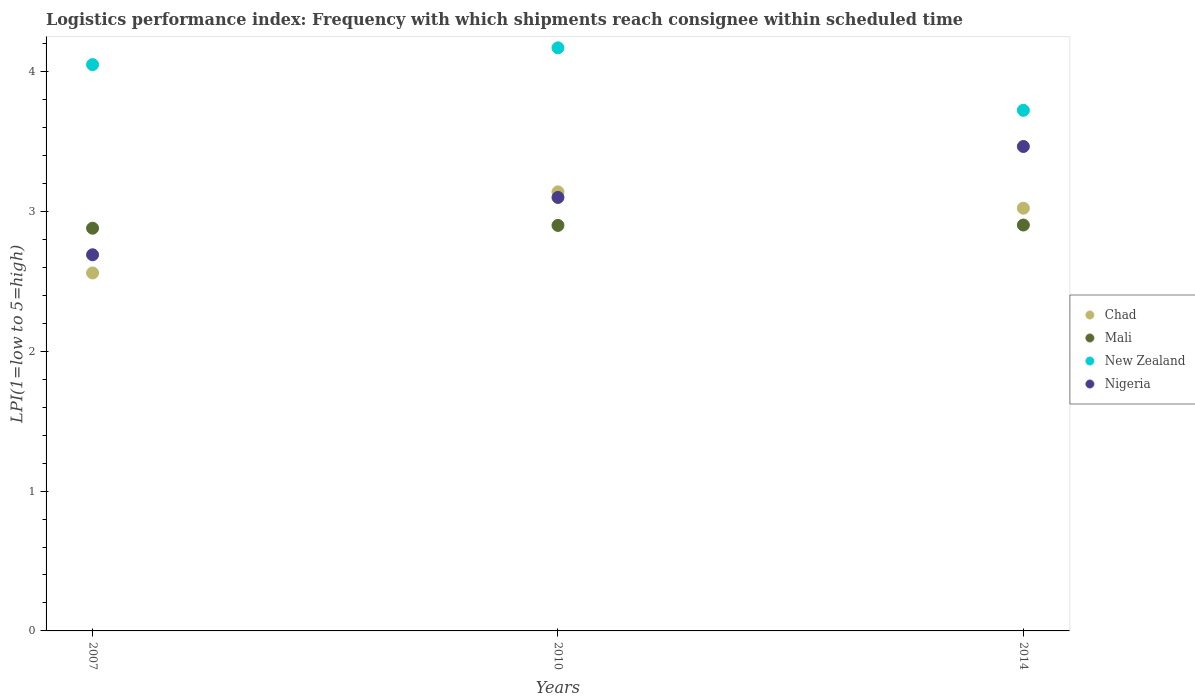What is the logistics performance index in Mali in 2014?
Your response must be concise. 2.9. Across all years, what is the maximum logistics performance index in Chad?
Offer a terse response. 3.14. Across all years, what is the minimum logistics performance index in Nigeria?
Your answer should be compact. 2.69. In which year was the logistics performance index in New Zealand minimum?
Offer a very short reply. 2014. What is the total logistics performance index in Chad in the graph?
Make the answer very short. 8.72. What is the difference between the logistics performance index in Nigeria in 2010 and that in 2014?
Offer a very short reply. -0.36. What is the difference between the logistics performance index in Chad in 2007 and the logistics performance index in Mali in 2010?
Your answer should be very brief. -0.34. What is the average logistics performance index in Mali per year?
Keep it short and to the point. 2.89. In the year 2007, what is the difference between the logistics performance index in Mali and logistics performance index in Nigeria?
Give a very brief answer. 0.19. In how many years, is the logistics performance index in Chad greater than 3.2?
Provide a succinct answer. 0. What is the ratio of the logistics performance index in New Zealand in 2007 to that in 2010?
Ensure brevity in your answer.  0.97. Is the logistics performance index in Nigeria in 2007 less than that in 2010?
Offer a terse response. Yes. What is the difference between the highest and the second highest logistics performance index in Nigeria?
Keep it short and to the point. 0.36. What is the difference between the highest and the lowest logistics performance index in Nigeria?
Provide a succinct answer. 0.77. Is the sum of the logistics performance index in Nigeria in 2007 and 2014 greater than the maximum logistics performance index in New Zealand across all years?
Provide a short and direct response. Yes. Is it the case that in every year, the sum of the logistics performance index in New Zealand and logistics performance index in Chad  is greater than the sum of logistics performance index in Mali and logistics performance index in Nigeria?
Provide a short and direct response. Yes. Is it the case that in every year, the sum of the logistics performance index in Chad and logistics performance index in Mali  is greater than the logistics performance index in Nigeria?
Make the answer very short. Yes. Does the logistics performance index in Nigeria monotonically increase over the years?
Ensure brevity in your answer.  Yes. Is the logistics performance index in Mali strictly greater than the logistics performance index in New Zealand over the years?
Ensure brevity in your answer.  No. Is the logistics performance index in Nigeria strictly less than the logistics performance index in Chad over the years?
Offer a very short reply. No. What is the difference between two consecutive major ticks on the Y-axis?
Provide a succinct answer. 1. Are the values on the major ticks of Y-axis written in scientific E-notation?
Your answer should be very brief. No. Does the graph contain any zero values?
Provide a succinct answer. No. Does the graph contain grids?
Ensure brevity in your answer.  No. Where does the legend appear in the graph?
Ensure brevity in your answer.  Center right. How many legend labels are there?
Provide a succinct answer. 4. How are the legend labels stacked?
Your answer should be very brief. Vertical. What is the title of the graph?
Offer a terse response. Logistics performance index: Frequency with which shipments reach consignee within scheduled time. Does "Yemen, Rep." appear as one of the legend labels in the graph?
Your answer should be compact. No. What is the label or title of the Y-axis?
Your response must be concise. LPI(1=low to 5=high). What is the LPI(1=low to 5=high) in Chad in 2007?
Your response must be concise. 2.56. What is the LPI(1=low to 5=high) in Mali in 2007?
Provide a succinct answer. 2.88. What is the LPI(1=low to 5=high) of New Zealand in 2007?
Ensure brevity in your answer.  4.05. What is the LPI(1=low to 5=high) in Nigeria in 2007?
Provide a short and direct response. 2.69. What is the LPI(1=low to 5=high) of Chad in 2010?
Make the answer very short. 3.14. What is the LPI(1=low to 5=high) of Mali in 2010?
Offer a terse response. 2.9. What is the LPI(1=low to 5=high) of New Zealand in 2010?
Provide a succinct answer. 4.17. What is the LPI(1=low to 5=high) in Nigeria in 2010?
Make the answer very short. 3.1. What is the LPI(1=low to 5=high) in Chad in 2014?
Provide a succinct answer. 3.02. What is the LPI(1=low to 5=high) in Mali in 2014?
Your response must be concise. 2.9. What is the LPI(1=low to 5=high) of New Zealand in 2014?
Keep it short and to the point. 3.72. What is the LPI(1=low to 5=high) of Nigeria in 2014?
Offer a very short reply. 3.46. Across all years, what is the maximum LPI(1=low to 5=high) of Chad?
Make the answer very short. 3.14. Across all years, what is the maximum LPI(1=low to 5=high) of Mali?
Your response must be concise. 2.9. Across all years, what is the maximum LPI(1=low to 5=high) of New Zealand?
Provide a succinct answer. 4.17. Across all years, what is the maximum LPI(1=low to 5=high) of Nigeria?
Ensure brevity in your answer.  3.46. Across all years, what is the minimum LPI(1=low to 5=high) in Chad?
Keep it short and to the point. 2.56. Across all years, what is the minimum LPI(1=low to 5=high) of Mali?
Provide a short and direct response. 2.88. Across all years, what is the minimum LPI(1=low to 5=high) of New Zealand?
Make the answer very short. 3.72. Across all years, what is the minimum LPI(1=low to 5=high) of Nigeria?
Your answer should be very brief. 2.69. What is the total LPI(1=low to 5=high) in Chad in the graph?
Keep it short and to the point. 8.72. What is the total LPI(1=low to 5=high) in Mali in the graph?
Offer a very short reply. 8.68. What is the total LPI(1=low to 5=high) in New Zealand in the graph?
Keep it short and to the point. 11.94. What is the total LPI(1=low to 5=high) of Nigeria in the graph?
Make the answer very short. 9.25. What is the difference between the LPI(1=low to 5=high) of Chad in 2007 and that in 2010?
Your answer should be very brief. -0.58. What is the difference between the LPI(1=low to 5=high) in Mali in 2007 and that in 2010?
Make the answer very short. -0.02. What is the difference between the LPI(1=low to 5=high) of New Zealand in 2007 and that in 2010?
Ensure brevity in your answer.  -0.12. What is the difference between the LPI(1=low to 5=high) in Nigeria in 2007 and that in 2010?
Give a very brief answer. -0.41. What is the difference between the LPI(1=low to 5=high) of Chad in 2007 and that in 2014?
Offer a very short reply. -0.46. What is the difference between the LPI(1=low to 5=high) of Mali in 2007 and that in 2014?
Offer a very short reply. -0.02. What is the difference between the LPI(1=low to 5=high) in New Zealand in 2007 and that in 2014?
Give a very brief answer. 0.33. What is the difference between the LPI(1=low to 5=high) of Nigeria in 2007 and that in 2014?
Make the answer very short. -0.77. What is the difference between the LPI(1=low to 5=high) of Chad in 2010 and that in 2014?
Your answer should be compact. 0.12. What is the difference between the LPI(1=low to 5=high) in Mali in 2010 and that in 2014?
Your response must be concise. -0. What is the difference between the LPI(1=low to 5=high) of New Zealand in 2010 and that in 2014?
Ensure brevity in your answer.  0.45. What is the difference between the LPI(1=low to 5=high) of Nigeria in 2010 and that in 2014?
Provide a short and direct response. -0.36. What is the difference between the LPI(1=low to 5=high) of Chad in 2007 and the LPI(1=low to 5=high) of Mali in 2010?
Your answer should be compact. -0.34. What is the difference between the LPI(1=low to 5=high) of Chad in 2007 and the LPI(1=low to 5=high) of New Zealand in 2010?
Your answer should be compact. -1.61. What is the difference between the LPI(1=low to 5=high) in Chad in 2007 and the LPI(1=low to 5=high) in Nigeria in 2010?
Ensure brevity in your answer.  -0.54. What is the difference between the LPI(1=low to 5=high) in Mali in 2007 and the LPI(1=low to 5=high) in New Zealand in 2010?
Provide a succinct answer. -1.29. What is the difference between the LPI(1=low to 5=high) of Mali in 2007 and the LPI(1=low to 5=high) of Nigeria in 2010?
Give a very brief answer. -0.22. What is the difference between the LPI(1=low to 5=high) in Chad in 2007 and the LPI(1=low to 5=high) in Mali in 2014?
Give a very brief answer. -0.34. What is the difference between the LPI(1=low to 5=high) in Chad in 2007 and the LPI(1=low to 5=high) in New Zealand in 2014?
Offer a very short reply. -1.16. What is the difference between the LPI(1=low to 5=high) in Chad in 2007 and the LPI(1=low to 5=high) in Nigeria in 2014?
Provide a short and direct response. -0.9. What is the difference between the LPI(1=low to 5=high) in Mali in 2007 and the LPI(1=low to 5=high) in New Zealand in 2014?
Provide a succinct answer. -0.84. What is the difference between the LPI(1=low to 5=high) of Mali in 2007 and the LPI(1=low to 5=high) of Nigeria in 2014?
Offer a very short reply. -0.58. What is the difference between the LPI(1=low to 5=high) of New Zealand in 2007 and the LPI(1=low to 5=high) of Nigeria in 2014?
Give a very brief answer. 0.59. What is the difference between the LPI(1=low to 5=high) of Chad in 2010 and the LPI(1=low to 5=high) of Mali in 2014?
Your answer should be compact. 0.24. What is the difference between the LPI(1=low to 5=high) in Chad in 2010 and the LPI(1=low to 5=high) in New Zealand in 2014?
Keep it short and to the point. -0.58. What is the difference between the LPI(1=low to 5=high) of Chad in 2010 and the LPI(1=low to 5=high) of Nigeria in 2014?
Ensure brevity in your answer.  -0.32. What is the difference between the LPI(1=low to 5=high) of Mali in 2010 and the LPI(1=low to 5=high) of New Zealand in 2014?
Your answer should be very brief. -0.82. What is the difference between the LPI(1=low to 5=high) in Mali in 2010 and the LPI(1=low to 5=high) in Nigeria in 2014?
Your answer should be very brief. -0.56. What is the difference between the LPI(1=low to 5=high) in New Zealand in 2010 and the LPI(1=low to 5=high) in Nigeria in 2014?
Ensure brevity in your answer.  0.71. What is the average LPI(1=low to 5=high) in Chad per year?
Keep it short and to the point. 2.91. What is the average LPI(1=low to 5=high) of Mali per year?
Provide a succinct answer. 2.89. What is the average LPI(1=low to 5=high) of New Zealand per year?
Keep it short and to the point. 3.98. What is the average LPI(1=low to 5=high) of Nigeria per year?
Make the answer very short. 3.08. In the year 2007, what is the difference between the LPI(1=low to 5=high) in Chad and LPI(1=low to 5=high) in Mali?
Your answer should be very brief. -0.32. In the year 2007, what is the difference between the LPI(1=low to 5=high) of Chad and LPI(1=low to 5=high) of New Zealand?
Your answer should be very brief. -1.49. In the year 2007, what is the difference between the LPI(1=low to 5=high) in Chad and LPI(1=low to 5=high) in Nigeria?
Your answer should be compact. -0.13. In the year 2007, what is the difference between the LPI(1=low to 5=high) in Mali and LPI(1=low to 5=high) in New Zealand?
Make the answer very short. -1.17. In the year 2007, what is the difference between the LPI(1=low to 5=high) in Mali and LPI(1=low to 5=high) in Nigeria?
Your answer should be compact. 0.19. In the year 2007, what is the difference between the LPI(1=low to 5=high) of New Zealand and LPI(1=low to 5=high) of Nigeria?
Give a very brief answer. 1.36. In the year 2010, what is the difference between the LPI(1=low to 5=high) in Chad and LPI(1=low to 5=high) in Mali?
Your answer should be compact. 0.24. In the year 2010, what is the difference between the LPI(1=low to 5=high) in Chad and LPI(1=low to 5=high) in New Zealand?
Provide a succinct answer. -1.03. In the year 2010, what is the difference between the LPI(1=low to 5=high) in Mali and LPI(1=low to 5=high) in New Zealand?
Keep it short and to the point. -1.27. In the year 2010, what is the difference between the LPI(1=low to 5=high) of New Zealand and LPI(1=low to 5=high) of Nigeria?
Provide a short and direct response. 1.07. In the year 2014, what is the difference between the LPI(1=low to 5=high) in Chad and LPI(1=low to 5=high) in Mali?
Your answer should be compact. 0.12. In the year 2014, what is the difference between the LPI(1=low to 5=high) in Chad and LPI(1=low to 5=high) in Nigeria?
Keep it short and to the point. -0.44. In the year 2014, what is the difference between the LPI(1=low to 5=high) of Mali and LPI(1=low to 5=high) of New Zealand?
Make the answer very short. -0.82. In the year 2014, what is the difference between the LPI(1=low to 5=high) of Mali and LPI(1=low to 5=high) of Nigeria?
Your answer should be compact. -0.56. In the year 2014, what is the difference between the LPI(1=low to 5=high) of New Zealand and LPI(1=low to 5=high) of Nigeria?
Your response must be concise. 0.26. What is the ratio of the LPI(1=low to 5=high) in Chad in 2007 to that in 2010?
Offer a terse response. 0.82. What is the ratio of the LPI(1=low to 5=high) in New Zealand in 2007 to that in 2010?
Give a very brief answer. 0.97. What is the ratio of the LPI(1=low to 5=high) of Nigeria in 2007 to that in 2010?
Offer a terse response. 0.87. What is the ratio of the LPI(1=low to 5=high) of Chad in 2007 to that in 2014?
Your answer should be very brief. 0.85. What is the ratio of the LPI(1=low to 5=high) in Mali in 2007 to that in 2014?
Offer a terse response. 0.99. What is the ratio of the LPI(1=low to 5=high) of New Zealand in 2007 to that in 2014?
Keep it short and to the point. 1.09. What is the ratio of the LPI(1=low to 5=high) of Nigeria in 2007 to that in 2014?
Your response must be concise. 0.78. What is the ratio of the LPI(1=low to 5=high) of Chad in 2010 to that in 2014?
Your answer should be very brief. 1.04. What is the ratio of the LPI(1=low to 5=high) of New Zealand in 2010 to that in 2014?
Give a very brief answer. 1.12. What is the ratio of the LPI(1=low to 5=high) of Nigeria in 2010 to that in 2014?
Keep it short and to the point. 0.89. What is the difference between the highest and the second highest LPI(1=low to 5=high) in Chad?
Ensure brevity in your answer.  0.12. What is the difference between the highest and the second highest LPI(1=low to 5=high) in Mali?
Make the answer very short. 0. What is the difference between the highest and the second highest LPI(1=low to 5=high) of New Zealand?
Make the answer very short. 0.12. What is the difference between the highest and the second highest LPI(1=low to 5=high) of Nigeria?
Your answer should be compact. 0.36. What is the difference between the highest and the lowest LPI(1=low to 5=high) in Chad?
Ensure brevity in your answer.  0.58. What is the difference between the highest and the lowest LPI(1=low to 5=high) of Mali?
Make the answer very short. 0.02. What is the difference between the highest and the lowest LPI(1=low to 5=high) in New Zealand?
Give a very brief answer. 0.45. What is the difference between the highest and the lowest LPI(1=low to 5=high) of Nigeria?
Your answer should be very brief. 0.77. 